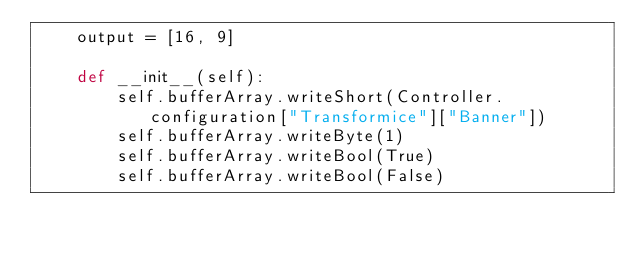Convert code to text. <code><loc_0><loc_0><loc_500><loc_500><_Python_>    output = [16, 9]

    def __init__(self):
        self.bufferArray.writeShort(Controller.configuration["Transformice"]["Banner"])
        self.bufferArray.writeByte(1)
        self.bufferArray.writeBool(True)
        self.bufferArray.writeBool(False)
</code> 